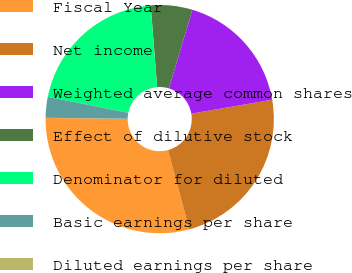Convert chart to OTSL. <chart><loc_0><loc_0><loc_500><loc_500><pie_chart><fcel>Fiscal Year<fcel>Net income<fcel>Weighted average common shares<fcel>Effect of dilutive stock<fcel>Denominator for diluted<fcel>Basic earnings per share<fcel>Diluted earnings per share<nl><fcel>29.34%<fcel>23.54%<fcel>17.67%<fcel>5.88%<fcel>20.61%<fcel>2.95%<fcel>0.02%<nl></chart> 